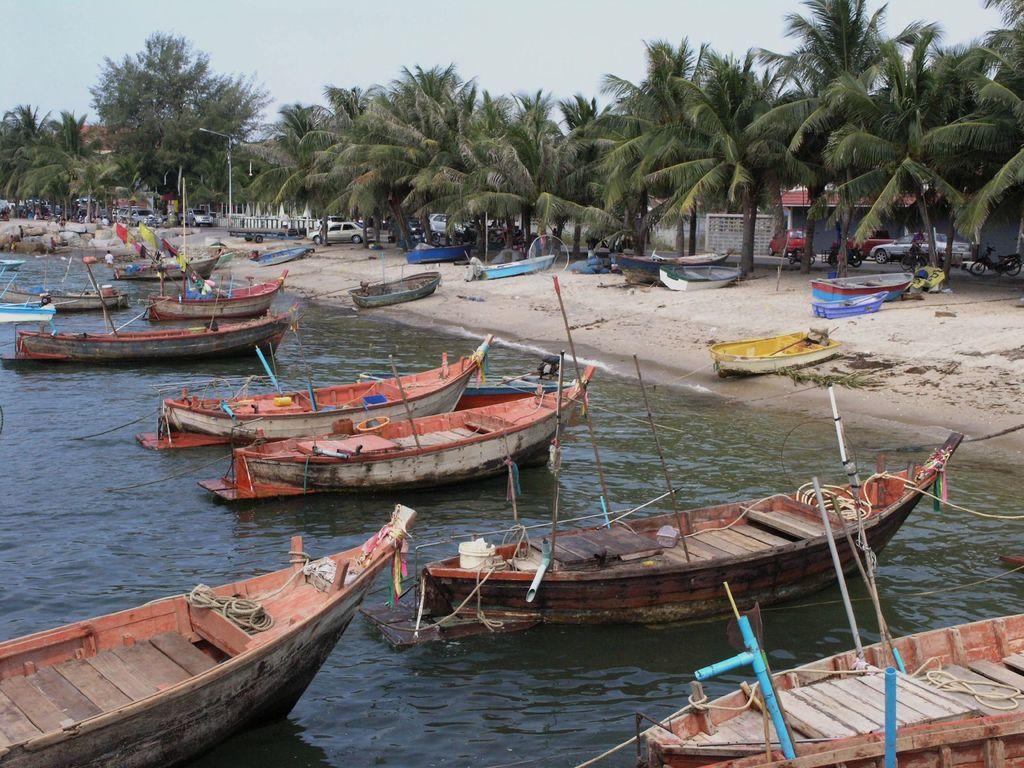Can you describe this image briefly? In this image few boats are in the water. Few boats are on the land having few vehicles and trees on it. Right side there are few bikes and car. Behind there is a house. Few persons are on the land. Background there are few trees. Top of image there is sky. 